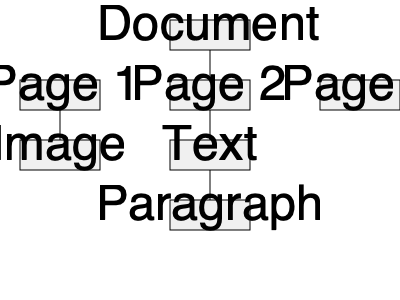Based on the hierarchical tree diagram of a sample PDF document, which page contains both an image and text elements, and what is the deepest level of nesting shown in the structure? To answer this question, let's analyze the diagram step by step:

1. The root of the tree is labeled "Document".
2. The document contains three pages: Page 1, Page 2, and Page 3.
3. Page 1 has a child element labeled "Image".
4. Page 2 has a child element labeled "Text".
5. The "Text" element on Page 2 has a child element labeled "Paragraph".
6. Page 3 doesn't have any visible child elements.

From this analysis, we can conclude:

a) Page 1 contains an image, while Page 2 contains text. No single page is shown to have both image and text elements.

b) The deepest level of nesting is found on Page 2:
   Document -> Page 2 -> Text -> Paragraph

This represents 3 levels of nesting below the root "Document" node.
Answer: No page shown has both; 3 levels 